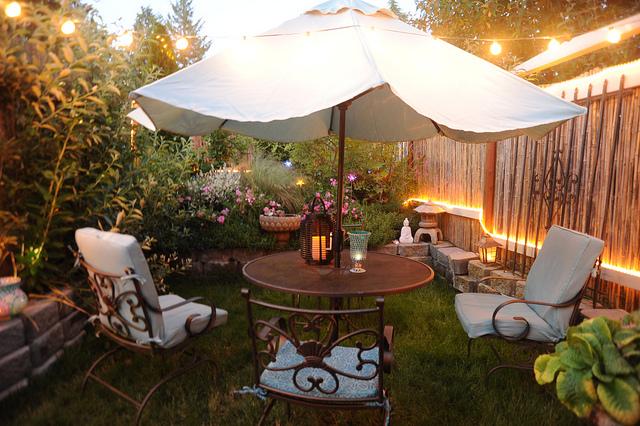How many chairs are near the patio table?
Give a very brief answer. 3. Is there flowers?
Quick response, please. Yes. What blocks the view to the right?
Keep it brief. Fence. 